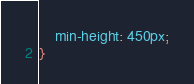Convert code to text. <code><loc_0><loc_0><loc_500><loc_500><_CSS_>    min-height: 450px;
}</code> 